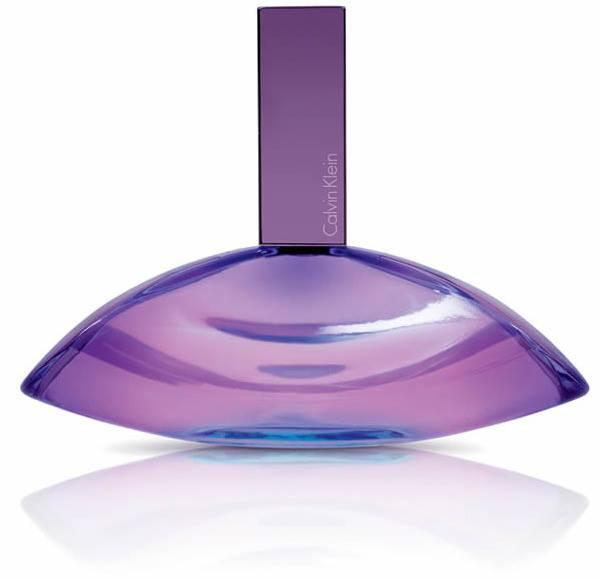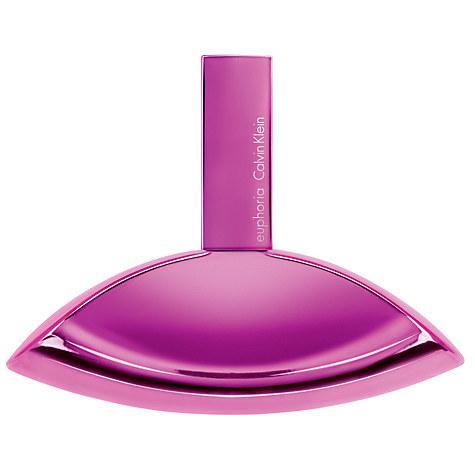The first image is the image on the left, the second image is the image on the right. Examine the images to the left and right. Is the description "There is a box beside the bottle in one of the images." accurate? Answer yes or no. No. 